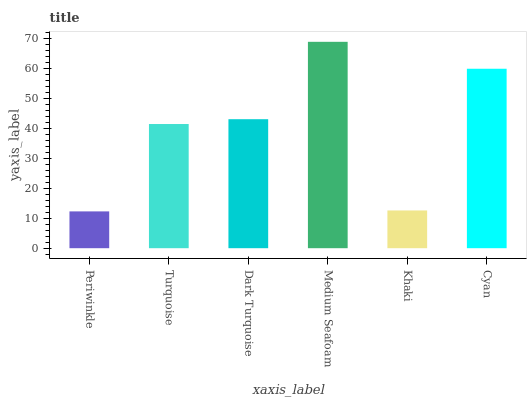Is Periwinkle the minimum?
Answer yes or no. Yes. Is Medium Seafoam the maximum?
Answer yes or no. Yes. Is Turquoise the minimum?
Answer yes or no. No. Is Turquoise the maximum?
Answer yes or no. No. Is Turquoise greater than Periwinkle?
Answer yes or no. Yes. Is Periwinkle less than Turquoise?
Answer yes or no. Yes. Is Periwinkle greater than Turquoise?
Answer yes or no. No. Is Turquoise less than Periwinkle?
Answer yes or no. No. Is Dark Turquoise the high median?
Answer yes or no. Yes. Is Turquoise the low median?
Answer yes or no. Yes. Is Cyan the high median?
Answer yes or no. No. Is Dark Turquoise the low median?
Answer yes or no. No. 